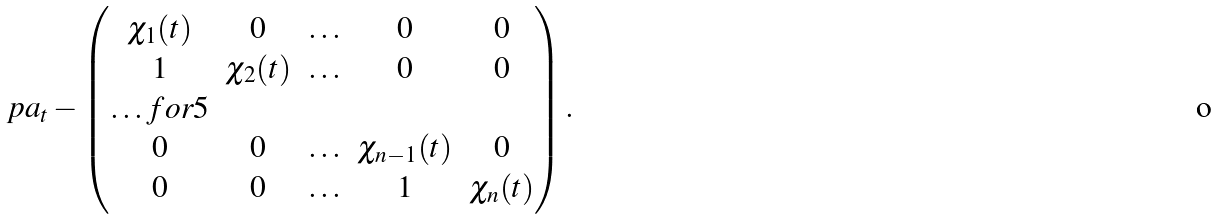<formula> <loc_0><loc_0><loc_500><loc_500>\ p a _ { t } - \begin{pmatrix} \chi _ { 1 } ( t ) & 0 & \hdots & 0 & 0 \\ 1 & \chi _ { 2 } ( t ) & \hdots & 0 & 0 \\ \hdots f o r { 5 } \\ 0 & 0 & \hdots & \chi _ { n - 1 } ( t ) & 0 \\ 0 & 0 & \hdots & 1 & \chi _ { n } ( t ) \end{pmatrix} .</formula> 